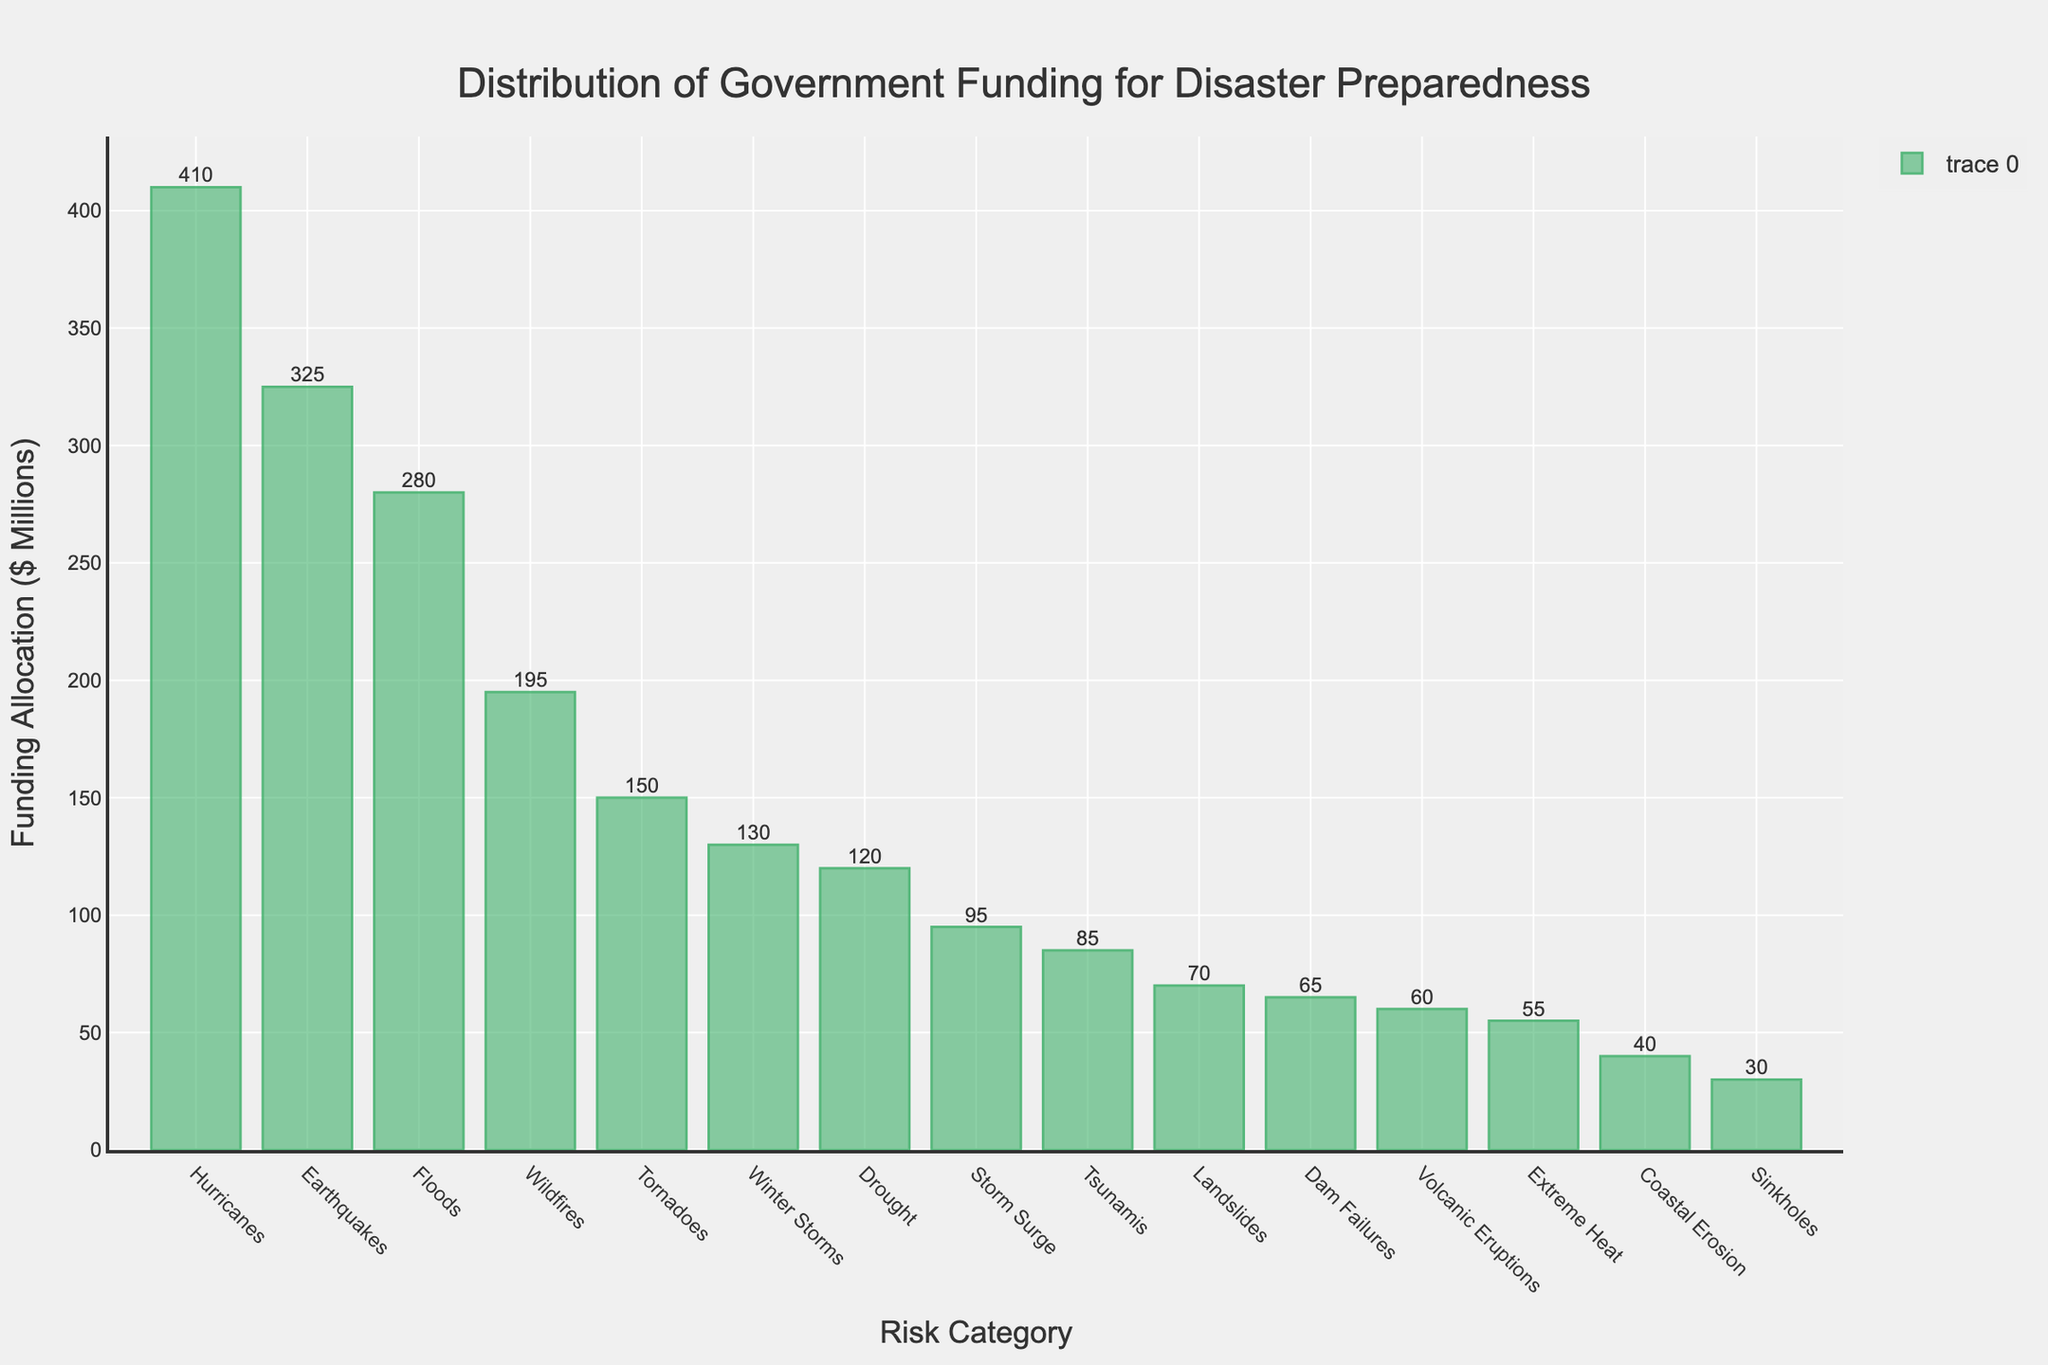Which risk category received the most funding? The risk category with the highest bar indicates the most funding. The bar for 'Hurricanes' is tallest.
Answer: Hurricanes Which risk category received the least funding? The shortest bar represents the category with the least funding. The bar for 'Sinkholes' is the shortest.
Answer: Sinkholes What is the total funding allocated to Earthquakes, Hurricanes, and Floods? Add the funding amounts for Earthquakes (325), Hurricanes (410), and Floods (280). 325 + 410 + 280 = 1015.
Answer: 1015 How much more funding do Hurricanes receive compared to Wildfires? Subtract the funding for Wildfires (195) from the funding for Hurricanes (410). 410 - 195 = 215.
Answer: 215 Which risk categories have a funding allocation greater than $300 million? Identify bars higher than $300 million. 'Earthquakes' and 'Hurricanes' meet this criterion.
Answer: Earthquakes, Hurricanes What is the average funding allocation for the top 3 funded risk categories? Add the top 3 funding amounts (Hurricanes, Earthquakes, Floods: 410 + 325 + 280) and divide by 3. (410 + 325 + 280) / 3 = 338.33.
Answer: 338.33 How does the funding for Tornadoes compare to that for Drought? Compare the heights of bars for Tornadoes (150) and Drought (120). Tornadoes receive more funding.
Answer: Tornadoes receive more funding Which two risk categories have the closest funding allocations? Look for bars with similar heights. 'Dam Failures' (65) and 'Landslides' (70) are close, with a difference of 5 units.
Answer: Dam Failures and Landslides What is the total funding for all categories under $100 million? Sum the allocations for categories under $100 million: Tsunamis (85), Volcanic Eruptions (60), Landslides (70), Extreme Heat (55), Storm Surge (95), Coastal Erosion (40), Sinkholes (30), Dam Failures (65). 85 + 60 + 70 + 55 + 95 + 40 + 30 + 65 = 500.
Answer: 500 